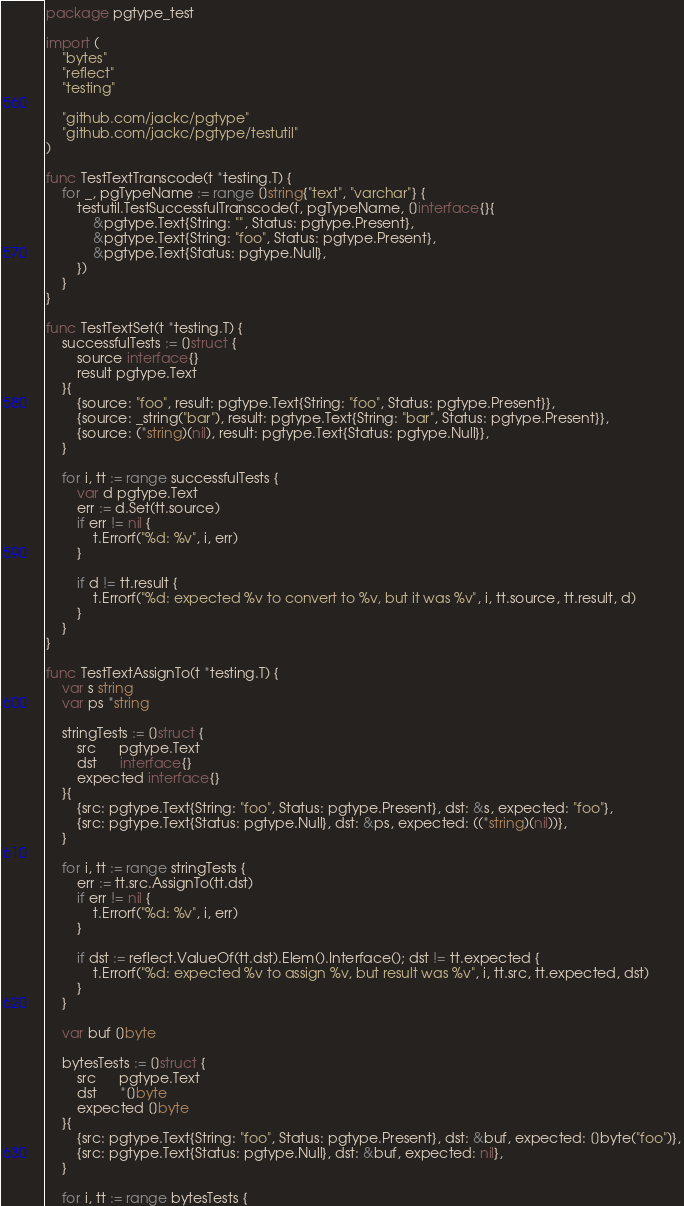Convert code to text. <code><loc_0><loc_0><loc_500><loc_500><_Go_>package pgtype_test

import (
	"bytes"
	"reflect"
	"testing"

	"github.com/jackc/pgtype"
	"github.com/jackc/pgtype/testutil"
)

func TestTextTranscode(t *testing.T) {
	for _, pgTypeName := range []string{"text", "varchar"} {
		testutil.TestSuccessfulTranscode(t, pgTypeName, []interface{}{
			&pgtype.Text{String: "", Status: pgtype.Present},
			&pgtype.Text{String: "foo", Status: pgtype.Present},
			&pgtype.Text{Status: pgtype.Null},
		})
	}
}

func TestTextSet(t *testing.T) {
	successfulTests := []struct {
		source interface{}
		result pgtype.Text
	}{
		{source: "foo", result: pgtype.Text{String: "foo", Status: pgtype.Present}},
		{source: _string("bar"), result: pgtype.Text{String: "bar", Status: pgtype.Present}},
		{source: (*string)(nil), result: pgtype.Text{Status: pgtype.Null}},
	}

	for i, tt := range successfulTests {
		var d pgtype.Text
		err := d.Set(tt.source)
		if err != nil {
			t.Errorf("%d: %v", i, err)
		}

		if d != tt.result {
			t.Errorf("%d: expected %v to convert to %v, but it was %v", i, tt.source, tt.result, d)
		}
	}
}

func TestTextAssignTo(t *testing.T) {
	var s string
	var ps *string

	stringTests := []struct {
		src      pgtype.Text
		dst      interface{}
		expected interface{}
	}{
		{src: pgtype.Text{String: "foo", Status: pgtype.Present}, dst: &s, expected: "foo"},
		{src: pgtype.Text{Status: pgtype.Null}, dst: &ps, expected: ((*string)(nil))},
	}

	for i, tt := range stringTests {
		err := tt.src.AssignTo(tt.dst)
		if err != nil {
			t.Errorf("%d: %v", i, err)
		}

		if dst := reflect.ValueOf(tt.dst).Elem().Interface(); dst != tt.expected {
			t.Errorf("%d: expected %v to assign %v, but result was %v", i, tt.src, tt.expected, dst)
		}
	}

	var buf []byte

	bytesTests := []struct {
		src      pgtype.Text
		dst      *[]byte
		expected []byte
	}{
		{src: pgtype.Text{String: "foo", Status: pgtype.Present}, dst: &buf, expected: []byte("foo")},
		{src: pgtype.Text{Status: pgtype.Null}, dst: &buf, expected: nil},
	}

	for i, tt := range bytesTests {</code> 